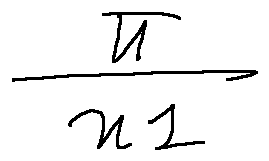<formula> <loc_0><loc_0><loc_500><loc_500>\frac { \pi } { x l }</formula> 